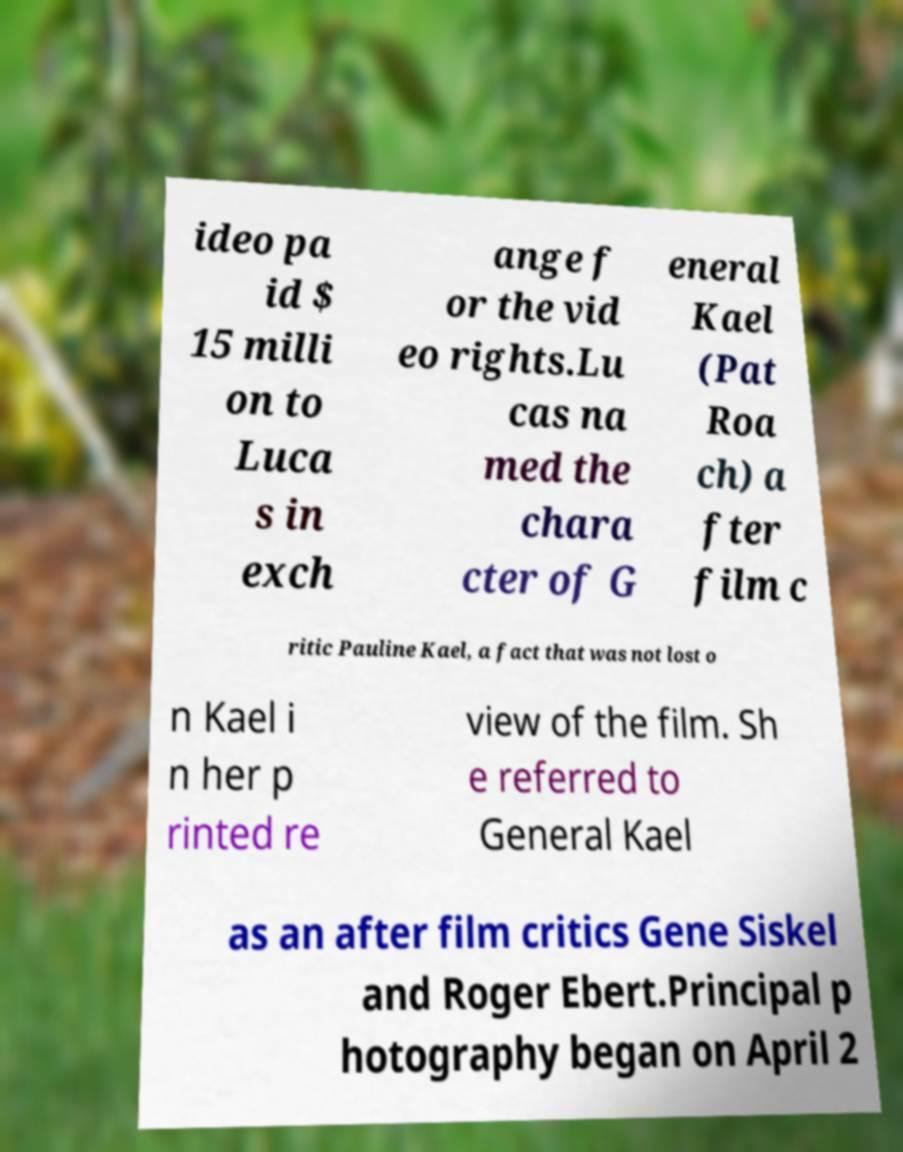Could you assist in decoding the text presented in this image and type it out clearly? ideo pa id $ 15 milli on to Luca s in exch ange f or the vid eo rights.Lu cas na med the chara cter of G eneral Kael (Pat Roa ch) a fter film c ritic Pauline Kael, a fact that was not lost o n Kael i n her p rinted re view of the film. Sh e referred to General Kael as an after film critics Gene Siskel and Roger Ebert.Principal p hotography began on April 2 